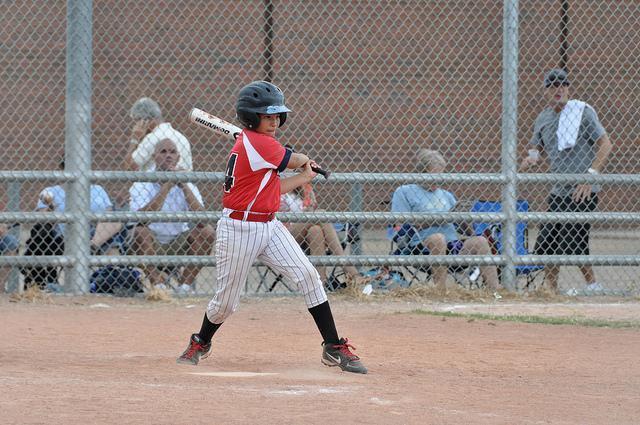How many people can be seen?
Give a very brief answer. 7. How many cats are in this photo?
Give a very brief answer. 0. 